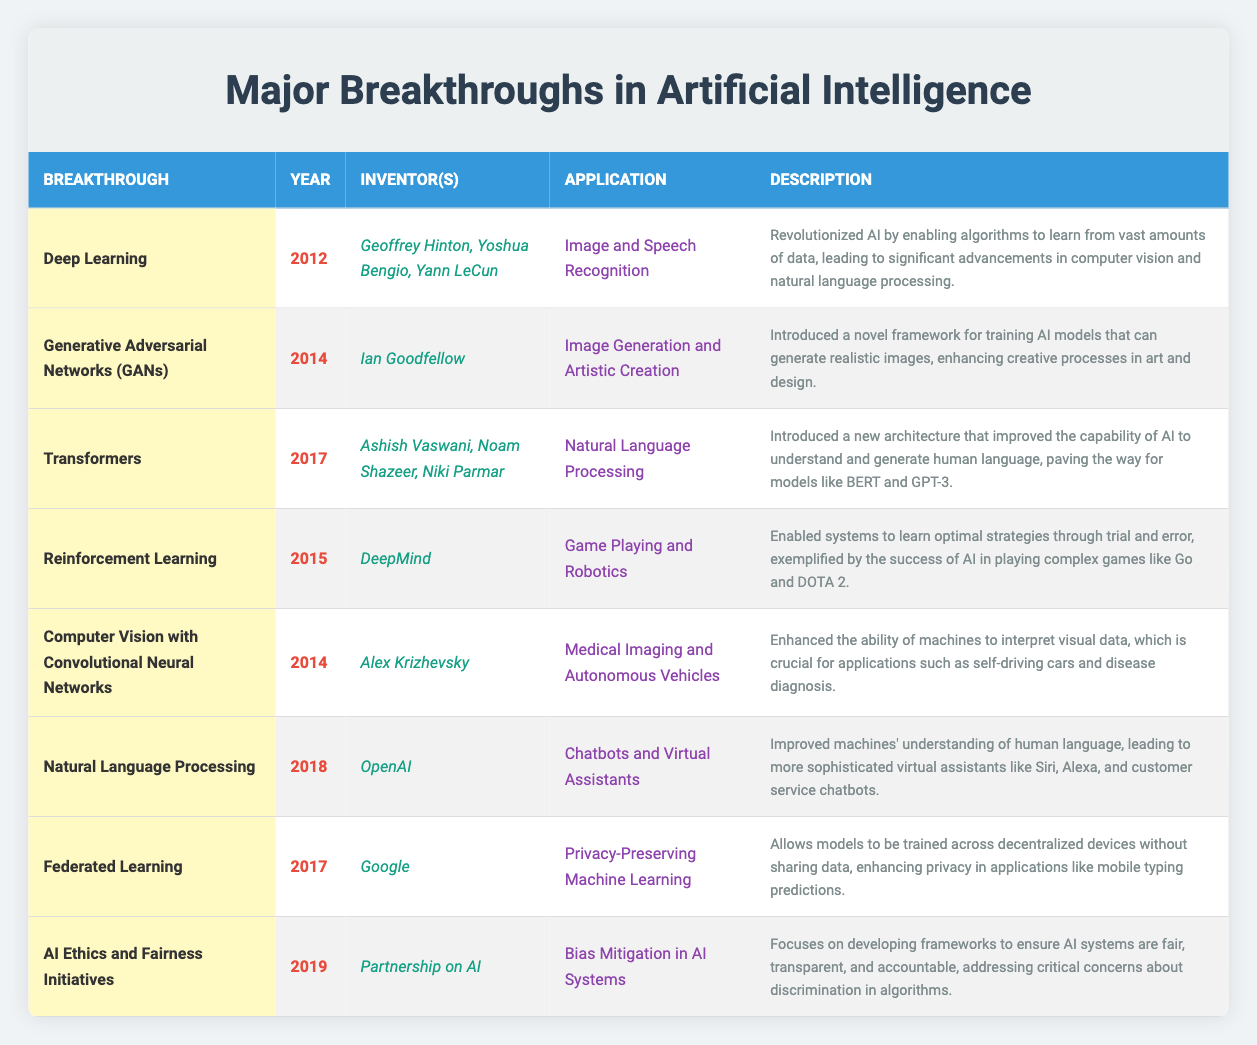What breakthrough in AI was introduced in 2012? Referring to the table, the year 2012 corresponds to the breakthrough of "Deep Learning".
Answer: Deep Learning Who are the inventors of Generative Adversarial Networks (GANs)? By looking at the row for GANs in the table, the inventors listed are Ian Goodfellow.
Answer: Ian Goodfellow Which applications are associated with Computer Vision using Convolutional Neural Networks? The application listed for Computer Vision with Convolutional Neural Networks in the table is "Medical Imaging and Autonomous Vehicles".
Answer: Medical Imaging and Autonomous Vehicles What year was Transformers introduced? The table shows that Transformers was introduced in the year 2017.
Answer: 2017 Is there a breakthrough in AI focused on Bias Mitigation? By checking the table, "AI Ethics and Fairness Initiatives" focuses on bias mitigation in AI systems.
Answer: Yes Which breakthrough focuses on privacy-preserving machine learning? The breakthrough related to privacy-preserving machine learning listed in the table is "Federated Learning".
Answer: Federated Learning How many pioneers were listed for Reinforcement Learning? The table indicates that there is one pioneer mentioned for Reinforcement Learning, which is DeepMind.
Answer: 1 In which year did Natural Language Processing significantly evolve? The table indicates that Natural Language Processing was improved in the year 2018.
Answer: 2018 What is the main application of Deep Learning? The main application mentioned for Deep Learning in the table is "Image and Speech Recognition".
Answer: Image and Speech Recognition What is the difference between the years of 'Deep Learning' and 'Reinforcement Learning'? Deep Learning was introduced in 2012, while Reinforcement Learning was introduced in 2015. The difference is 2015 - 2012 = 3 years.
Answer: 3 years Which breakthroughs were introduced in 2014? The table shows that both "Generative Adversarial Networks (GANs)" and "Computer Vision with Convolutional Neural Networks" were introduced in 2014.
Answer: 2 breakthroughs Are there any breakthroughs listed that have the same inventor? Checking the table reveals that the inventor for both "Deep Learning" and "Transformers" includes names of multiple inventors, thus they do not match the same individuals directly. However, typical inventors for "Deep Learning" and "Transformers" are distinct.
Answer: No What was the application of the breakthrough that came after Federated Learning? The breakthrough after Federated Learning, according to the table, is "AI Ethics and Fairness Initiatives", which focuses on "Bias Mitigation in AI Systems".
Answer: Bias Mitigation in AI Systems Which breakthrough’s description mentions creative processes in art and design? The breakthrough that includes creative processes in its description is "Generative Adversarial Networks (GANs)".
Answer: Generative Adversarial Networks (GANs) 